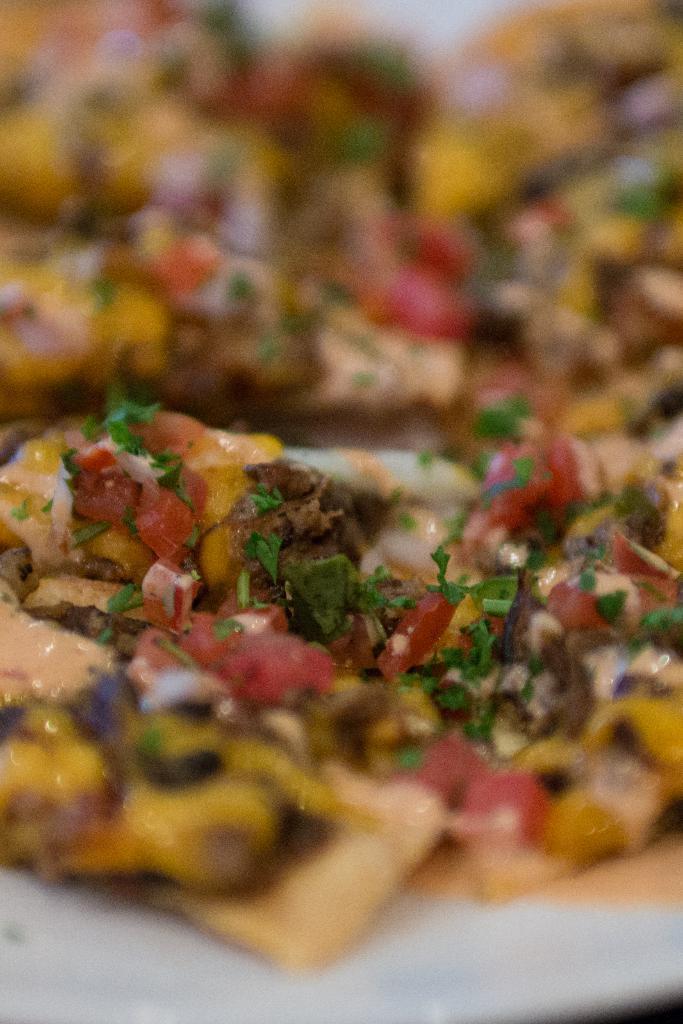Describe this image in one or two sentences. In this picture we can see food. 